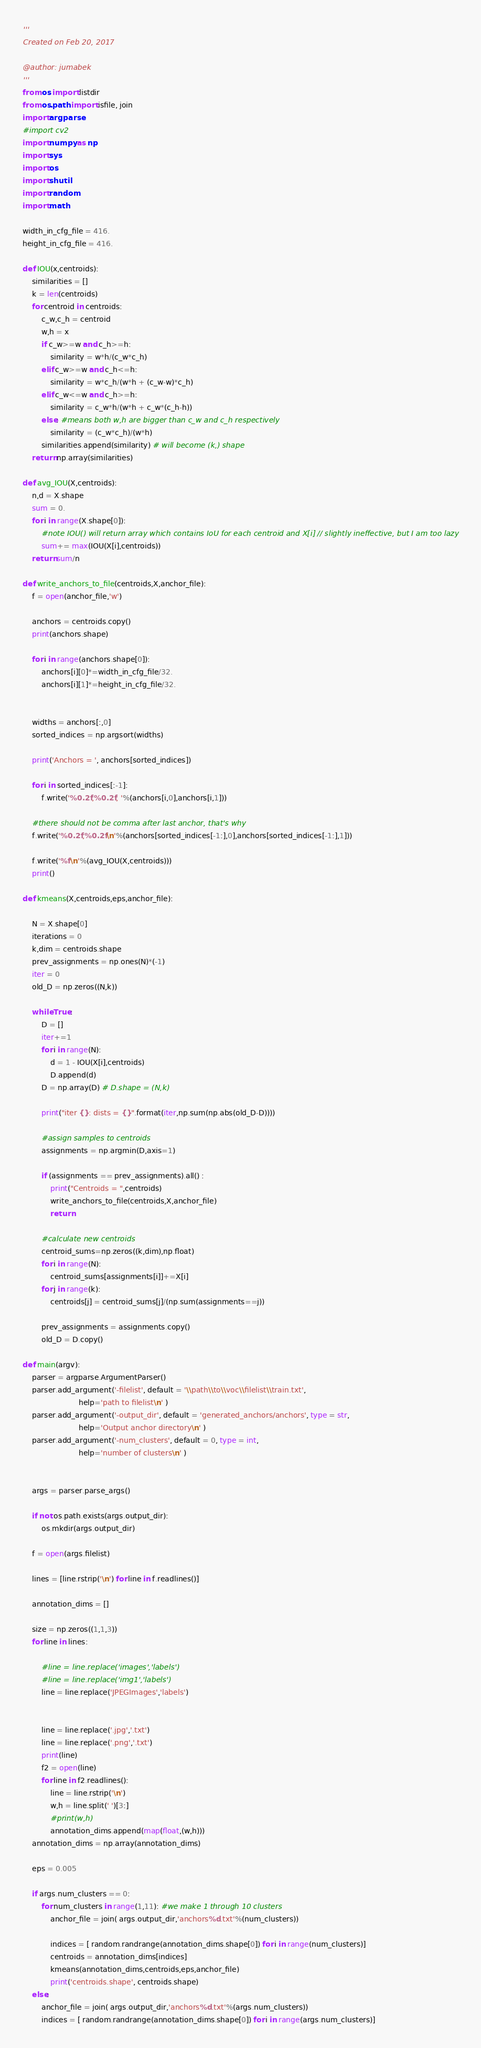Convert code to text. <code><loc_0><loc_0><loc_500><loc_500><_Python_>'''
Created on Feb 20, 2017

@author: jumabek
'''
from os import listdir
from os.path import isfile, join
import argparse
#import cv2
import numpy as np
import sys
import os
import shutil
import random 
import math

width_in_cfg_file = 416.
height_in_cfg_file = 416.

def IOU(x,centroids):
    similarities = []
    k = len(centroids)
    for centroid in centroids:
        c_w,c_h = centroid
        w,h = x
        if c_w>=w and c_h>=h:
            similarity = w*h/(c_w*c_h)
        elif c_w>=w and c_h<=h:
            similarity = w*c_h/(w*h + (c_w-w)*c_h)
        elif c_w<=w and c_h>=h:
            similarity = c_w*h/(w*h + c_w*(c_h-h))
        else: #means both w,h are bigger than c_w and c_h respectively
            similarity = (c_w*c_h)/(w*h)
        similarities.append(similarity) # will become (k,) shape
    return np.array(similarities) 

def avg_IOU(X,centroids):
    n,d = X.shape
    sum = 0.
    for i in range(X.shape[0]):
        #note IOU() will return array which contains IoU for each centroid and X[i] // slightly ineffective, but I am too lazy
        sum+= max(IOU(X[i],centroids)) 
    return sum/n

def write_anchors_to_file(centroids,X,anchor_file):
    f = open(anchor_file,'w')
    
    anchors = centroids.copy()
    print(anchors.shape)

    for i in range(anchors.shape[0]):
        anchors[i][0]*=width_in_cfg_file/32.
        anchors[i][1]*=height_in_cfg_file/32.
         

    widths = anchors[:,0]
    sorted_indices = np.argsort(widths)

    print('Anchors = ', anchors[sorted_indices])
        
    for i in sorted_indices[:-1]:
        f.write('%0.2f,%0.2f, '%(anchors[i,0],anchors[i,1]))

    #there should not be comma after last anchor, that's why
    f.write('%0.2f,%0.2f\n'%(anchors[sorted_indices[-1:],0],anchors[sorted_indices[-1:],1]))
    
    f.write('%f\n'%(avg_IOU(X,centroids)))
    print()

def kmeans(X,centroids,eps,anchor_file):
    
    N = X.shape[0]
    iterations = 0
    k,dim = centroids.shape
    prev_assignments = np.ones(N)*(-1)    
    iter = 0
    old_D = np.zeros((N,k))

    while True:
        D = [] 
        iter+=1           
        for i in range(N):
            d = 1 - IOU(X[i],centroids)
            D.append(d)
        D = np.array(D) # D.shape = (N,k)
        
        print("iter {}: dists = {}".format(iter,np.sum(np.abs(old_D-D))))
            
        #assign samples to centroids 
        assignments = np.argmin(D,axis=1)
        
        if (assignments == prev_assignments).all() :
            print("Centroids = ",centroids)
            write_anchors_to_file(centroids,X,anchor_file)
            return

        #calculate new centroids
        centroid_sums=np.zeros((k,dim),np.float)
        for i in range(N):
            centroid_sums[assignments[i]]+=X[i]        
        for j in range(k):            
            centroids[j] = centroid_sums[j]/(np.sum(assignments==j))
        
        prev_assignments = assignments.copy()     
        old_D = D.copy()  

def main(argv):
    parser = argparse.ArgumentParser()
    parser.add_argument('-filelist', default = '\\path\\to\\voc\\filelist\\train.txt', 
                        help='path to filelist\n' )
    parser.add_argument('-output_dir', default = 'generated_anchors/anchors', type = str, 
                        help='Output anchor directory\n' )  
    parser.add_argument('-num_clusters', default = 0, type = int, 
                        help='number of clusters\n' )  

   
    args = parser.parse_args()
    
    if not os.path.exists(args.output_dir):
        os.mkdir(args.output_dir)

    f = open(args.filelist)
  
    lines = [line.rstrip('\n') for line in f.readlines()]
    
    annotation_dims = []

    size = np.zeros((1,1,3))
    for line in lines:
                    
        #line = line.replace('images','labels')
        #line = line.replace('img1','labels')
        line = line.replace('JPEGImages','labels')        
        

        line = line.replace('.jpg','.txt')
        line = line.replace('.png','.txt')
        print(line)
        f2 = open(line)
        for line in f2.readlines():
            line = line.rstrip('\n')
            w,h = line.split(' ')[3:]            
            #print(w,h)
            annotation_dims.append(map(float,(w,h)))
    annotation_dims = np.array(annotation_dims)
  
    eps = 0.005
    
    if args.num_clusters == 0:
        for num_clusters in range(1,11): #we make 1 through 10 clusters 
            anchor_file = join( args.output_dir,'anchors%d.txt'%(num_clusters))

            indices = [ random.randrange(annotation_dims.shape[0]) for i in range(num_clusters)]
            centroids = annotation_dims[indices]
            kmeans(annotation_dims,centroids,eps,anchor_file)
            print('centroids.shape', centroids.shape)
    else:
        anchor_file = join( args.output_dir,'anchors%d.txt'%(args.num_clusters))
        indices = [ random.randrange(annotation_dims.shape[0]) for i in range(args.num_clusters)]</code> 